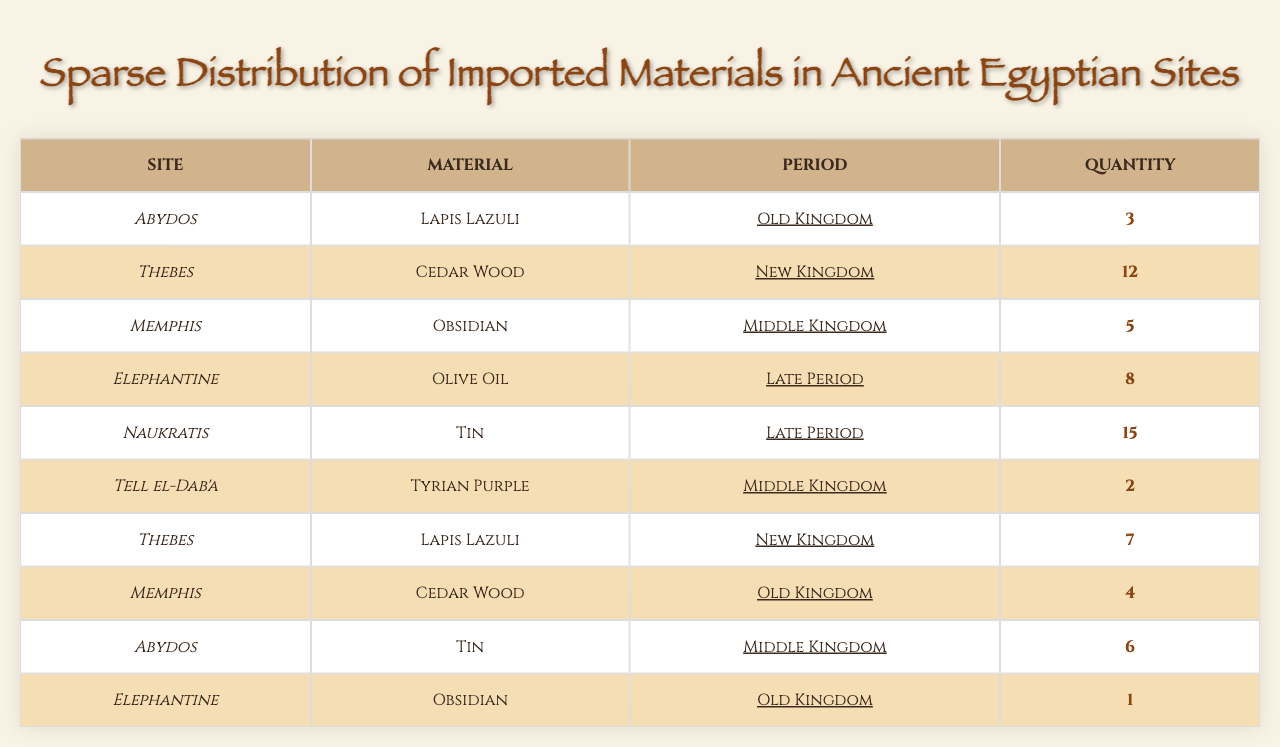What material was imported to Thebes during the New Kingdom? The table shows that Cedar Wood was imported to Thebes during the New Kingdom with a quantity of 12.
Answer: Cedar Wood Which site imported the highest quantity of Tin? The table lists Naukratis as the site that imported Tin during the Late Period with a quantity of 15, which is the highest shown in the data.
Answer: Naukratis How many different materials were imported to Elephantine? For Elephantine, the table shows only one material, Olive Oil, during the Late Period. Therefore, the count of different materials is 1.
Answer: 1 What is the total quantity of imported materials from Memphis? In Memphis, there are two entries: 5 for Obsidian during the Middle Kingdom and 4 for Cedar Wood during the Old Kingdom. Summing these gives a total of 5 + 4 = 9.
Answer: 9 Did Abydos import any materials during the New Kingdom? The data does not list any entries for Abydos in the New Kingdom, indicating that no materials were imported during that period.
Answer: No What is the average quantity of imported materials across all sites in the Middle Kingdom? The total for the Middle Kingdom includes 5 (Memphis, Obsidian) + 6 (Abydos, Tin) + 2 (Tell el-Dab'a, Tyrian Purple) = 13. There are three data points, so the average is 13 / 3 = 4.33.
Answer: 4.33 Which material was imported in the largest quantity, and where? The largest quantity was 15 for Tin at Naukratis during the Late Period, according to the table.
Answer: Tin at Naukratis How many sites imported Lapis Lazuli, and what were the quantities? The table shows that Lapis Lazuli was imported at Abydos (3) and Thebes (7), giving a total of 2 sites with quantities of 3 and 7, respectively.
Answer: 2 sites (3 at Abydos and 7 at Thebes) 